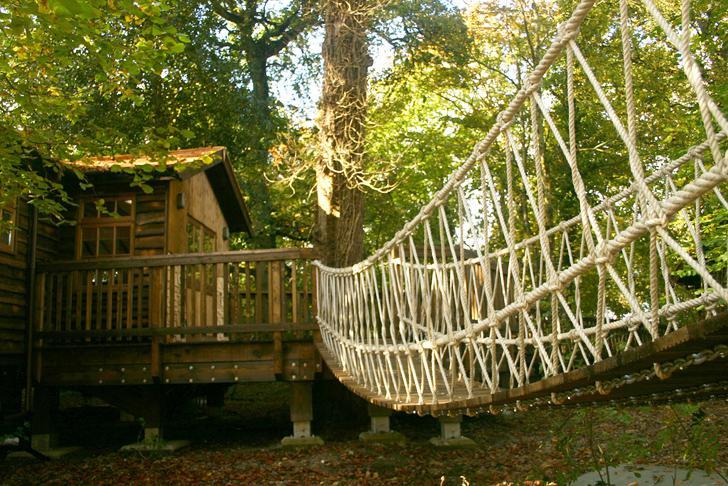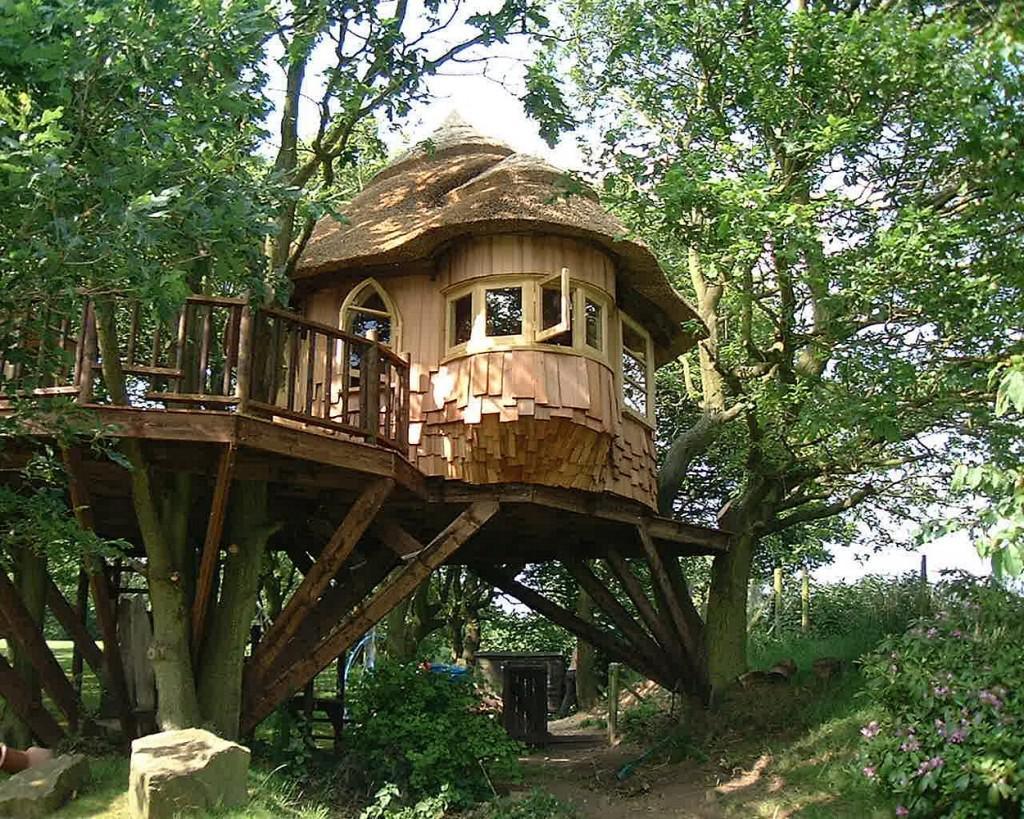The first image is the image on the left, the second image is the image on the right. Assess this claim about the two images: "A rope walkway leads from the lower left to an elevated treehouse surrounded by a deck with railing.". Correct or not? Answer yes or no. No. The first image is the image on the left, the second image is the image on the right. Assess this claim about the two images: "there is a tree house with a bridge leading to it, in front of the house there are two tree trunks and there is one trunk behind". Correct or not? Answer yes or no. No. 